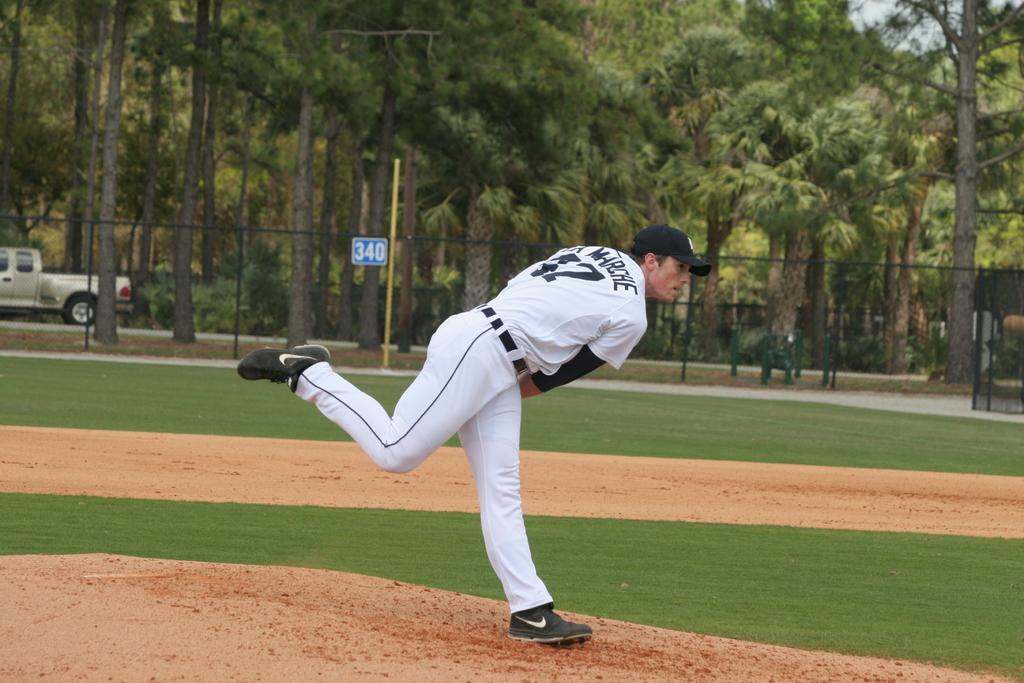<image>
Write a terse but informative summary of the picture. A baseball pitcher is throwing the ball and a blue sign says 340 behind him. 